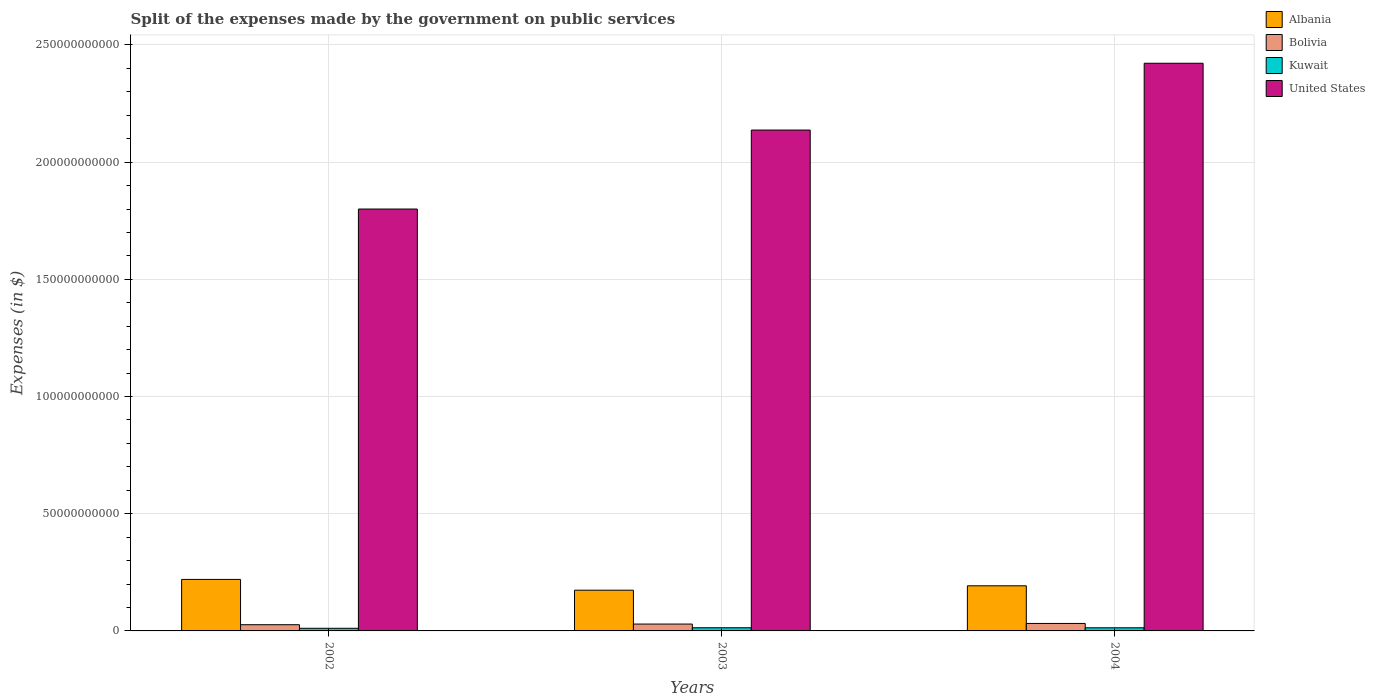How many different coloured bars are there?
Provide a short and direct response. 4. How many groups of bars are there?
Your answer should be very brief. 3. Are the number of bars per tick equal to the number of legend labels?
Your answer should be very brief. Yes. How many bars are there on the 3rd tick from the left?
Provide a succinct answer. 4. How many bars are there on the 2nd tick from the right?
Make the answer very short. 4. In how many cases, is the number of bars for a given year not equal to the number of legend labels?
Your answer should be very brief. 0. What is the expenses made by the government on public services in Albania in 2004?
Your answer should be very brief. 1.93e+1. Across all years, what is the maximum expenses made by the government on public services in Bolivia?
Your answer should be very brief. 3.19e+09. Across all years, what is the minimum expenses made by the government on public services in United States?
Make the answer very short. 1.80e+11. In which year was the expenses made by the government on public services in Kuwait maximum?
Offer a very short reply. 2003. What is the total expenses made by the government on public services in United States in the graph?
Your response must be concise. 6.36e+11. What is the difference between the expenses made by the government on public services in Albania in 2003 and that in 2004?
Offer a terse response. -1.88e+09. What is the difference between the expenses made by the government on public services in United States in 2003 and the expenses made by the government on public services in Albania in 2004?
Your response must be concise. 1.94e+11. What is the average expenses made by the government on public services in United States per year?
Offer a very short reply. 2.12e+11. In the year 2002, what is the difference between the expenses made by the government on public services in United States and expenses made by the government on public services in Bolivia?
Your answer should be very brief. 1.77e+11. In how many years, is the expenses made by the government on public services in United States greater than 110000000000 $?
Provide a succinct answer. 3. What is the ratio of the expenses made by the government on public services in Albania in 2003 to that in 2004?
Make the answer very short. 0.9. Is the expenses made by the government on public services in United States in 2002 less than that in 2004?
Make the answer very short. Yes. Is the difference between the expenses made by the government on public services in United States in 2002 and 2003 greater than the difference between the expenses made by the government on public services in Bolivia in 2002 and 2003?
Ensure brevity in your answer.  No. What is the difference between the highest and the second highest expenses made by the government on public services in United States?
Provide a succinct answer. 2.85e+1. What is the difference between the highest and the lowest expenses made by the government on public services in Kuwait?
Give a very brief answer. 2.26e+08. In how many years, is the expenses made by the government on public services in United States greater than the average expenses made by the government on public services in United States taken over all years?
Provide a succinct answer. 2. What does the 1st bar from the left in 2004 represents?
Offer a terse response. Albania. Are all the bars in the graph horizontal?
Offer a terse response. No. How many years are there in the graph?
Provide a short and direct response. 3. What is the difference between two consecutive major ticks on the Y-axis?
Your response must be concise. 5.00e+1. Are the values on the major ticks of Y-axis written in scientific E-notation?
Provide a short and direct response. No. Does the graph contain grids?
Your response must be concise. Yes. How many legend labels are there?
Your answer should be very brief. 4. What is the title of the graph?
Offer a very short reply. Split of the expenses made by the government on public services. What is the label or title of the Y-axis?
Your response must be concise. Expenses (in $). What is the Expenses (in $) in Albania in 2002?
Offer a terse response. 2.20e+1. What is the Expenses (in $) of Bolivia in 2002?
Offer a very short reply. 2.65e+09. What is the Expenses (in $) in Kuwait in 2002?
Offer a very short reply. 1.12e+09. What is the Expenses (in $) in United States in 2002?
Provide a succinct answer. 1.80e+11. What is the Expenses (in $) of Albania in 2003?
Your answer should be compact. 1.74e+1. What is the Expenses (in $) of Bolivia in 2003?
Offer a terse response. 2.93e+09. What is the Expenses (in $) in Kuwait in 2003?
Your answer should be very brief. 1.35e+09. What is the Expenses (in $) in United States in 2003?
Offer a terse response. 2.14e+11. What is the Expenses (in $) in Albania in 2004?
Ensure brevity in your answer.  1.93e+1. What is the Expenses (in $) of Bolivia in 2004?
Your answer should be very brief. 3.19e+09. What is the Expenses (in $) of Kuwait in 2004?
Offer a terse response. 1.34e+09. What is the Expenses (in $) in United States in 2004?
Your answer should be compact. 2.42e+11. Across all years, what is the maximum Expenses (in $) in Albania?
Offer a very short reply. 2.20e+1. Across all years, what is the maximum Expenses (in $) of Bolivia?
Provide a short and direct response. 3.19e+09. Across all years, what is the maximum Expenses (in $) in Kuwait?
Offer a very short reply. 1.35e+09. Across all years, what is the maximum Expenses (in $) of United States?
Your answer should be compact. 2.42e+11. Across all years, what is the minimum Expenses (in $) in Albania?
Your answer should be compact. 1.74e+1. Across all years, what is the minimum Expenses (in $) of Bolivia?
Your answer should be very brief. 2.65e+09. Across all years, what is the minimum Expenses (in $) in Kuwait?
Provide a succinct answer. 1.12e+09. Across all years, what is the minimum Expenses (in $) of United States?
Your response must be concise. 1.80e+11. What is the total Expenses (in $) in Albania in the graph?
Your answer should be very brief. 5.86e+1. What is the total Expenses (in $) of Bolivia in the graph?
Give a very brief answer. 8.77e+09. What is the total Expenses (in $) in Kuwait in the graph?
Make the answer very short. 3.81e+09. What is the total Expenses (in $) in United States in the graph?
Provide a short and direct response. 6.36e+11. What is the difference between the Expenses (in $) in Albania in 2002 and that in 2003?
Ensure brevity in your answer.  4.60e+09. What is the difference between the Expenses (in $) of Bolivia in 2002 and that in 2003?
Ensure brevity in your answer.  -2.81e+08. What is the difference between the Expenses (in $) of Kuwait in 2002 and that in 2003?
Offer a terse response. -2.26e+08. What is the difference between the Expenses (in $) of United States in 2002 and that in 2003?
Provide a short and direct response. -3.37e+1. What is the difference between the Expenses (in $) of Albania in 2002 and that in 2004?
Offer a terse response. 2.72e+09. What is the difference between the Expenses (in $) in Bolivia in 2002 and that in 2004?
Your response must be concise. -5.42e+08. What is the difference between the Expenses (in $) in Kuwait in 2002 and that in 2004?
Give a very brief answer. -2.11e+08. What is the difference between the Expenses (in $) of United States in 2002 and that in 2004?
Make the answer very short. -6.22e+1. What is the difference between the Expenses (in $) of Albania in 2003 and that in 2004?
Your answer should be very brief. -1.88e+09. What is the difference between the Expenses (in $) of Bolivia in 2003 and that in 2004?
Ensure brevity in your answer.  -2.61e+08. What is the difference between the Expenses (in $) in Kuwait in 2003 and that in 2004?
Keep it short and to the point. 1.50e+07. What is the difference between the Expenses (in $) in United States in 2003 and that in 2004?
Ensure brevity in your answer.  -2.85e+1. What is the difference between the Expenses (in $) in Albania in 2002 and the Expenses (in $) in Bolivia in 2003?
Provide a short and direct response. 1.90e+1. What is the difference between the Expenses (in $) of Albania in 2002 and the Expenses (in $) of Kuwait in 2003?
Your response must be concise. 2.06e+1. What is the difference between the Expenses (in $) in Albania in 2002 and the Expenses (in $) in United States in 2003?
Ensure brevity in your answer.  -1.92e+11. What is the difference between the Expenses (in $) in Bolivia in 2002 and the Expenses (in $) in Kuwait in 2003?
Offer a very short reply. 1.30e+09. What is the difference between the Expenses (in $) of Bolivia in 2002 and the Expenses (in $) of United States in 2003?
Make the answer very short. -2.11e+11. What is the difference between the Expenses (in $) of Kuwait in 2002 and the Expenses (in $) of United States in 2003?
Your response must be concise. -2.13e+11. What is the difference between the Expenses (in $) in Albania in 2002 and the Expenses (in $) in Bolivia in 2004?
Provide a short and direct response. 1.88e+1. What is the difference between the Expenses (in $) in Albania in 2002 and the Expenses (in $) in Kuwait in 2004?
Provide a succinct answer. 2.06e+1. What is the difference between the Expenses (in $) in Albania in 2002 and the Expenses (in $) in United States in 2004?
Give a very brief answer. -2.20e+11. What is the difference between the Expenses (in $) of Bolivia in 2002 and the Expenses (in $) of Kuwait in 2004?
Make the answer very short. 1.31e+09. What is the difference between the Expenses (in $) of Bolivia in 2002 and the Expenses (in $) of United States in 2004?
Ensure brevity in your answer.  -2.40e+11. What is the difference between the Expenses (in $) of Kuwait in 2002 and the Expenses (in $) of United States in 2004?
Ensure brevity in your answer.  -2.41e+11. What is the difference between the Expenses (in $) in Albania in 2003 and the Expenses (in $) in Bolivia in 2004?
Your response must be concise. 1.42e+1. What is the difference between the Expenses (in $) in Albania in 2003 and the Expenses (in $) in Kuwait in 2004?
Offer a terse response. 1.60e+1. What is the difference between the Expenses (in $) in Albania in 2003 and the Expenses (in $) in United States in 2004?
Your answer should be very brief. -2.25e+11. What is the difference between the Expenses (in $) in Bolivia in 2003 and the Expenses (in $) in Kuwait in 2004?
Your response must be concise. 1.59e+09. What is the difference between the Expenses (in $) in Bolivia in 2003 and the Expenses (in $) in United States in 2004?
Provide a short and direct response. -2.39e+11. What is the difference between the Expenses (in $) in Kuwait in 2003 and the Expenses (in $) in United States in 2004?
Ensure brevity in your answer.  -2.41e+11. What is the average Expenses (in $) of Albania per year?
Provide a succinct answer. 1.95e+1. What is the average Expenses (in $) of Bolivia per year?
Your answer should be very brief. 2.92e+09. What is the average Expenses (in $) in Kuwait per year?
Your answer should be compact. 1.27e+09. What is the average Expenses (in $) of United States per year?
Your answer should be compact. 2.12e+11. In the year 2002, what is the difference between the Expenses (in $) of Albania and Expenses (in $) of Bolivia?
Ensure brevity in your answer.  1.93e+1. In the year 2002, what is the difference between the Expenses (in $) in Albania and Expenses (in $) in Kuwait?
Offer a very short reply. 2.09e+1. In the year 2002, what is the difference between the Expenses (in $) of Albania and Expenses (in $) of United States?
Make the answer very short. -1.58e+11. In the year 2002, what is the difference between the Expenses (in $) of Bolivia and Expenses (in $) of Kuwait?
Make the answer very short. 1.52e+09. In the year 2002, what is the difference between the Expenses (in $) of Bolivia and Expenses (in $) of United States?
Your answer should be compact. -1.77e+11. In the year 2002, what is the difference between the Expenses (in $) of Kuwait and Expenses (in $) of United States?
Your answer should be compact. -1.79e+11. In the year 2003, what is the difference between the Expenses (in $) of Albania and Expenses (in $) of Bolivia?
Provide a short and direct response. 1.44e+1. In the year 2003, what is the difference between the Expenses (in $) of Albania and Expenses (in $) of Kuwait?
Offer a terse response. 1.60e+1. In the year 2003, what is the difference between the Expenses (in $) in Albania and Expenses (in $) in United States?
Your answer should be very brief. -1.96e+11. In the year 2003, what is the difference between the Expenses (in $) in Bolivia and Expenses (in $) in Kuwait?
Provide a succinct answer. 1.58e+09. In the year 2003, what is the difference between the Expenses (in $) in Bolivia and Expenses (in $) in United States?
Provide a short and direct response. -2.11e+11. In the year 2003, what is the difference between the Expenses (in $) of Kuwait and Expenses (in $) of United States?
Provide a short and direct response. -2.12e+11. In the year 2004, what is the difference between the Expenses (in $) of Albania and Expenses (in $) of Bolivia?
Your answer should be compact. 1.61e+1. In the year 2004, what is the difference between the Expenses (in $) in Albania and Expenses (in $) in Kuwait?
Your answer should be compact. 1.79e+1. In the year 2004, what is the difference between the Expenses (in $) of Albania and Expenses (in $) of United States?
Offer a very short reply. -2.23e+11. In the year 2004, what is the difference between the Expenses (in $) in Bolivia and Expenses (in $) in Kuwait?
Make the answer very short. 1.86e+09. In the year 2004, what is the difference between the Expenses (in $) in Bolivia and Expenses (in $) in United States?
Offer a terse response. -2.39e+11. In the year 2004, what is the difference between the Expenses (in $) of Kuwait and Expenses (in $) of United States?
Your response must be concise. -2.41e+11. What is the ratio of the Expenses (in $) of Albania in 2002 to that in 2003?
Your answer should be very brief. 1.26. What is the ratio of the Expenses (in $) in Bolivia in 2002 to that in 2003?
Offer a terse response. 0.9. What is the ratio of the Expenses (in $) of Kuwait in 2002 to that in 2003?
Your response must be concise. 0.83. What is the ratio of the Expenses (in $) of United States in 2002 to that in 2003?
Your answer should be very brief. 0.84. What is the ratio of the Expenses (in $) in Albania in 2002 to that in 2004?
Your response must be concise. 1.14. What is the ratio of the Expenses (in $) of Bolivia in 2002 to that in 2004?
Offer a terse response. 0.83. What is the ratio of the Expenses (in $) of Kuwait in 2002 to that in 2004?
Offer a terse response. 0.84. What is the ratio of the Expenses (in $) of United States in 2002 to that in 2004?
Your answer should be compact. 0.74. What is the ratio of the Expenses (in $) of Albania in 2003 to that in 2004?
Your answer should be very brief. 0.9. What is the ratio of the Expenses (in $) in Bolivia in 2003 to that in 2004?
Give a very brief answer. 0.92. What is the ratio of the Expenses (in $) in Kuwait in 2003 to that in 2004?
Give a very brief answer. 1.01. What is the ratio of the Expenses (in $) of United States in 2003 to that in 2004?
Your answer should be compact. 0.88. What is the difference between the highest and the second highest Expenses (in $) of Albania?
Give a very brief answer. 2.72e+09. What is the difference between the highest and the second highest Expenses (in $) in Bolivia?
Provide a short and direct response. 2.61e+08. What is the difference between the highest and the second highest Expenses (in $) of Kuwait?
Offer a terse response. 1.50e+07. What is the difference between the highest and the second highest Expenses (in $) in United States?
Offer a very short reply. 2.85e+1. What is the difference between the highest and the lowest Expenses (in $) in Albania?
Offer a terse response. 4.60e+09. What is the difference between the highest and the lowest Expenses (in $) of Bolivia?
Provide a short and direct response. 5.42e+08. What is the difference between the highest and the lowest Expenses (in $) in Kuwait?
Make the answer very short. 2.26e+08. What is the difference between the highest and the lowest Expenses (in $) of United States?
Offer a terse response. 6.22e+1. 